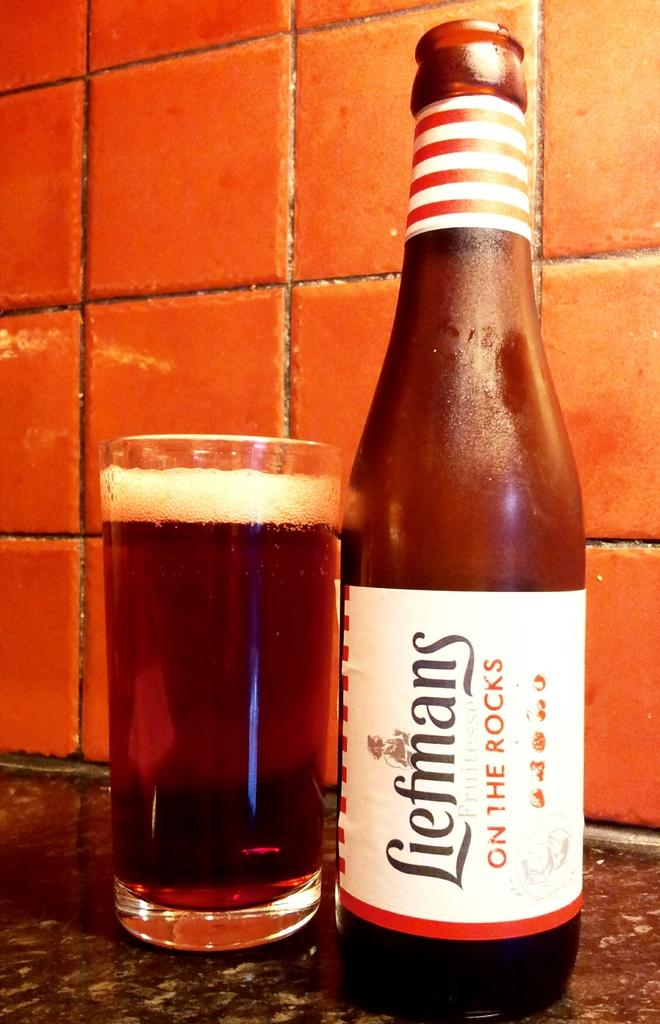Provide a one-sentence caption for the provided image. A bottle of chilled Liefmans served on the counter. 